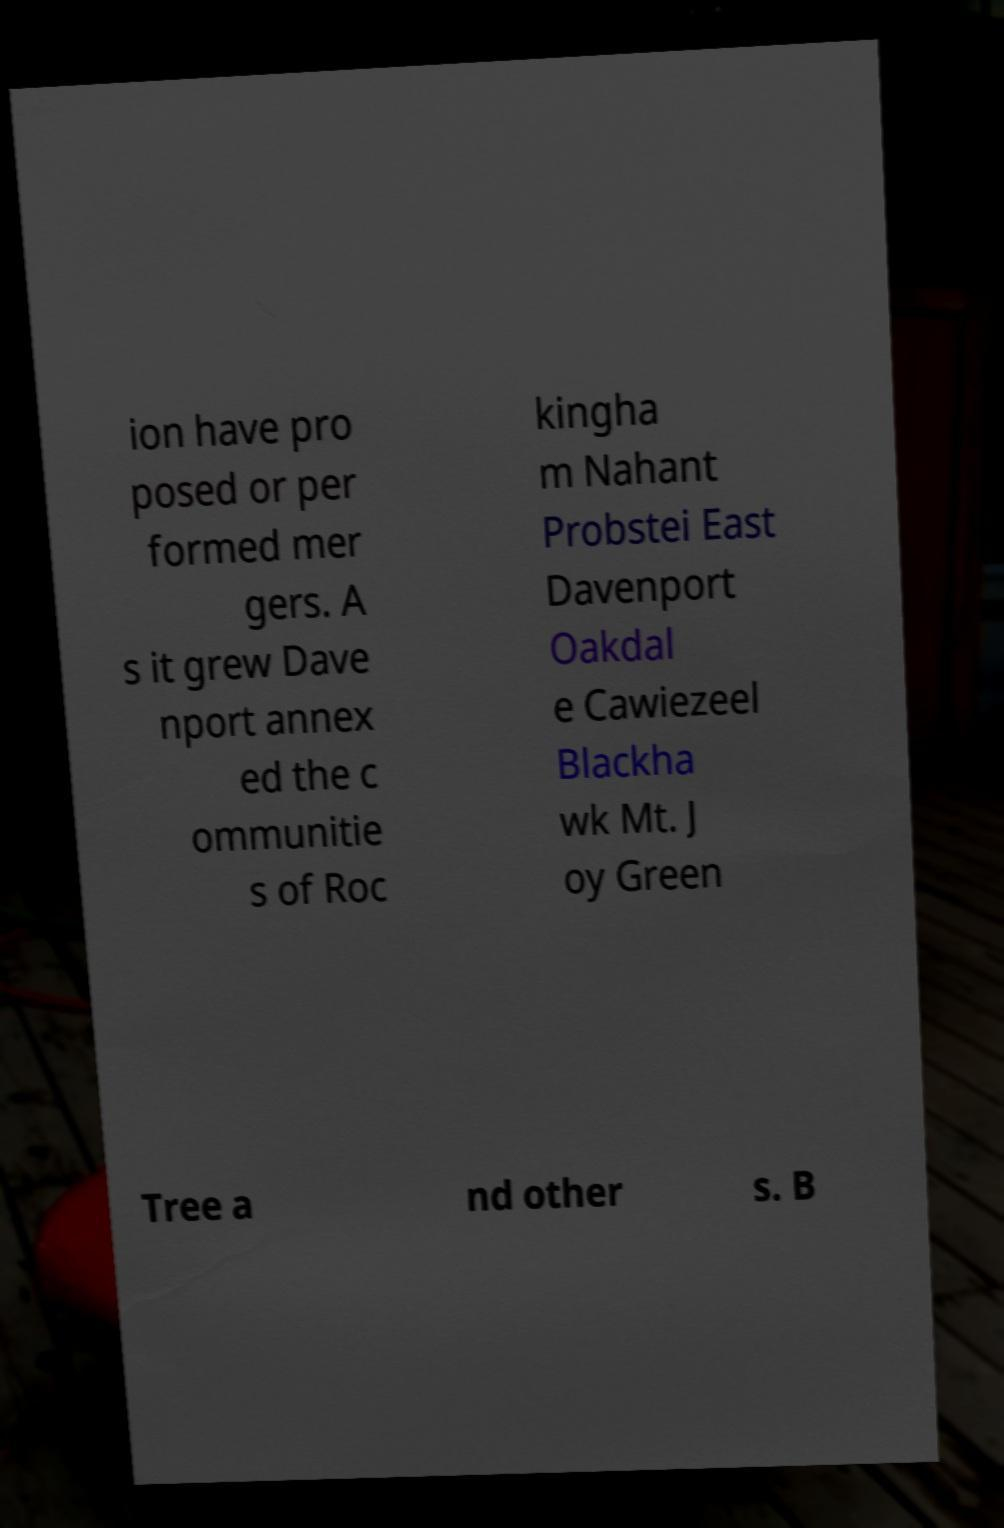Can you accurately transcribe the text from the provided image for me? ion have pro posed or per formed mer gers. A s it grew Dave nport annex ed the c ommunitie s of Roc kingha m Nahant Probstei East Davenport Oakdal e Cawiezeel Blackha wk Mt. J oy Green Tree a nd other s. B 